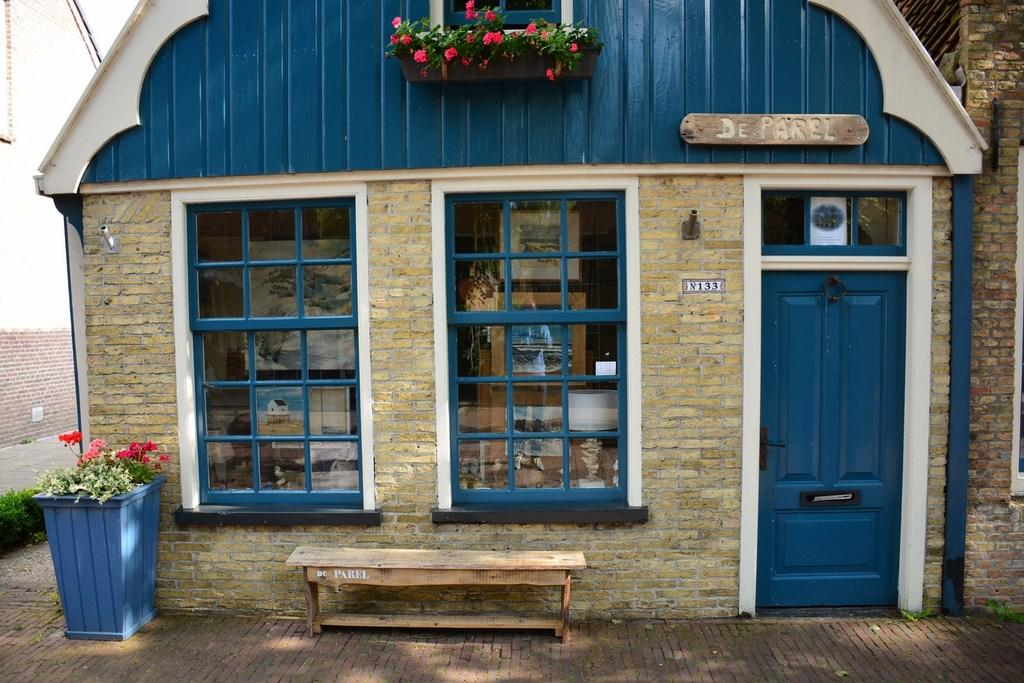What type of structure is visible in the image? There is a house in the image. What can be seen in front of the house? There are flowers and a bench in front of the house. How many deer are visible behind the house in the image? There are no deer present in the image; it only shows a house, flowers, and a bench in front of the house. 